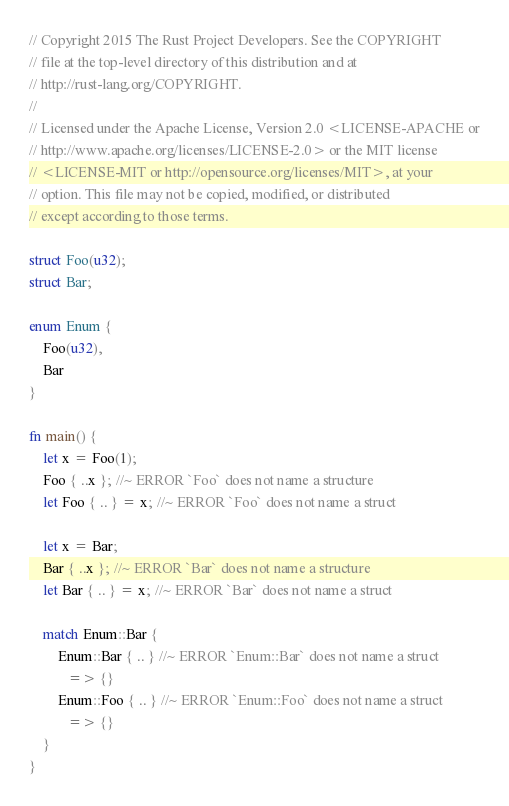<code> <loc_0><loc_0><loc_500><loc_500><_Rust_>// Copyright 2015 The Rust Project Developers. See the COPYRIGHT
// file at the top-level directory of this distribution and at
// http://rust-lang.org/COPYRIGHT.
//
// Licensed under the Apache License, Version 2.0 <LICENSE-APACHE or
// http://www.apache.org/licenses/LICENSE-2.0> or the MIT license
// <LICENSE-MIT or http://opensource.org/licenses/MIT>, at your
// option. This file may not be copied, modified, or distributed
// except according to those terms.

struct Foo(u32);
struct Bar;

enum Enum {
    Foo(u32),
    Bar
}

fn main() {
    let x = Foo(1);
    Foo { ..x }; //~ ERROR `Foo` does not name a structure
    let Foo { .. } = x; //~ ERROR `Foo` does not name a struct

    let x = Bar;
    Bar { ..x }; //~ ERROR `Bar` does not name a structure
    let Bar { .. } = x; //~ ERROR `Bar` does not name a struct

    match Enum::Bar {
        Enum::Bar { .. } //~ ERROR `Enum::Bar` does not name a struct
           => {}
        Enum::Foo { .. } //~ ERROR `Enum::Foo` does not name a struct
           => {}
    }
}
</code> 